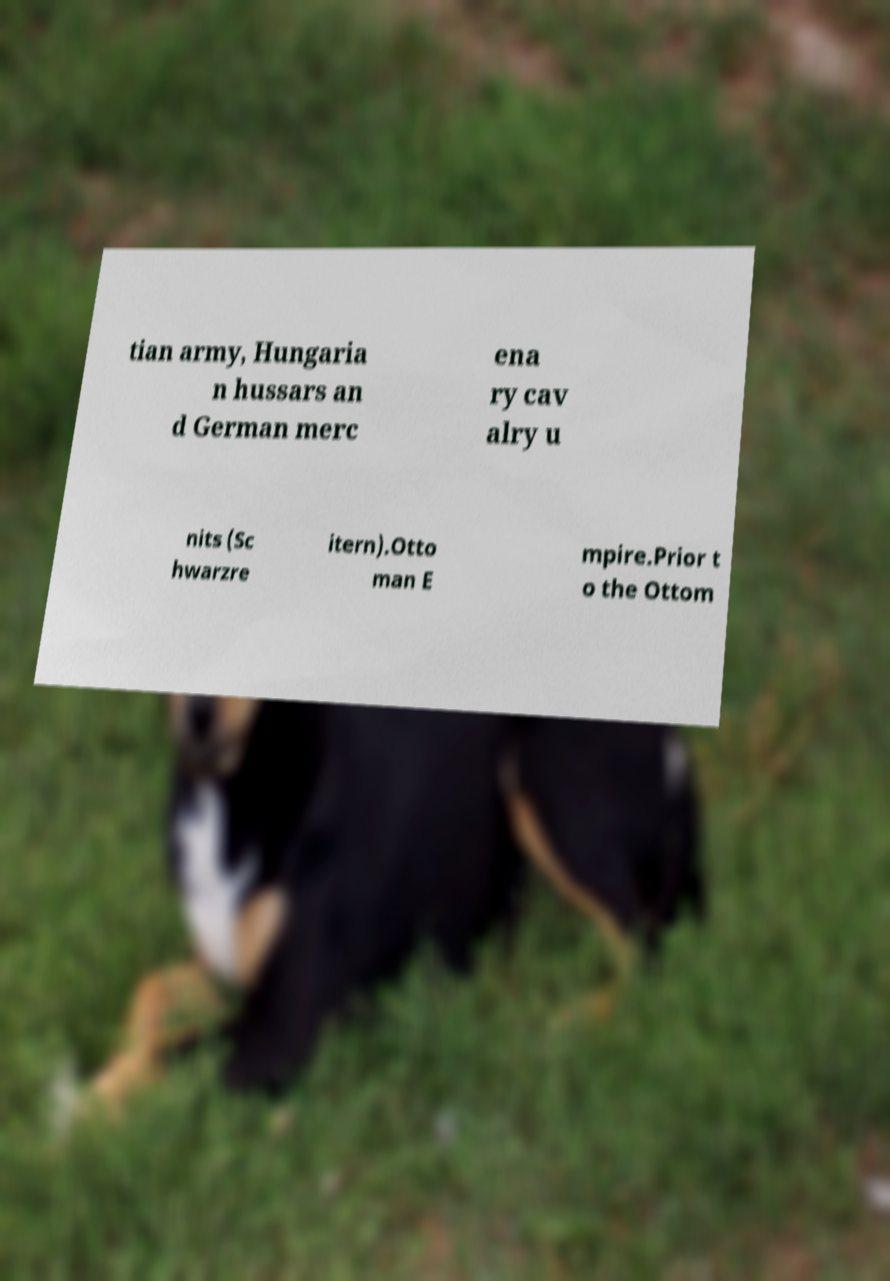I need the written content from this picture converted into text. Can you do that? tian army, Hungaria n hussars an d German merc ena ry cav alry u nits (Sc hwarzre itern).Otto man E mpire.Prior t o the Ottom 